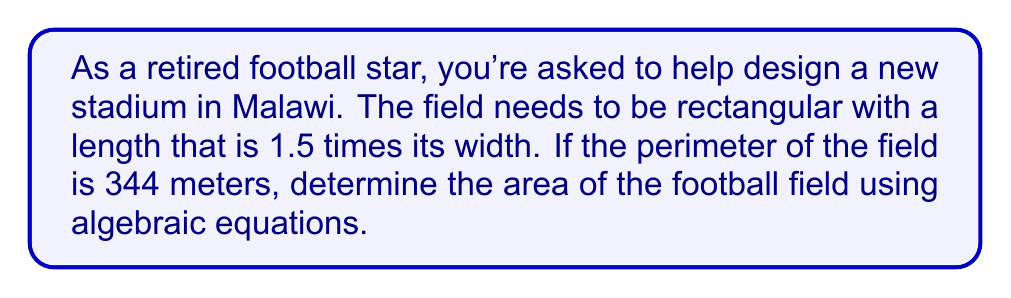Give your solution to this math problem. Let's approach this step-by-step:

1) Let $w$ represent the width of the field and $l$ represent the length.

2) Given that the length is 1.5 times the width, we can express $l$ in terms of $w$:
   
   $l = 1.5w$

3) The perimeter of a rectangle is given by the formula $2l + 2w = 344$

4) Substituting $l$ with $1.5w$:
   
   $2(1.5w) + 2w = 344$
   $3w + 2w = 344$
   $5w = 344$

5) Solving for $w$:
   
   $w = \frac{344}{5} = 68.8$ meters

6) Now we can calculate $l$:
   
   $l = 1.5w = 1.5(68.8) = 103.2$ meters

7) The area of a rectangle is given by $A = lw$

8) Therefore, the area is:
   
   $A = 103.2 \times 68.8 = 7100.16$ square meters
Answer: $7100.16 \text{ m}^2$ 